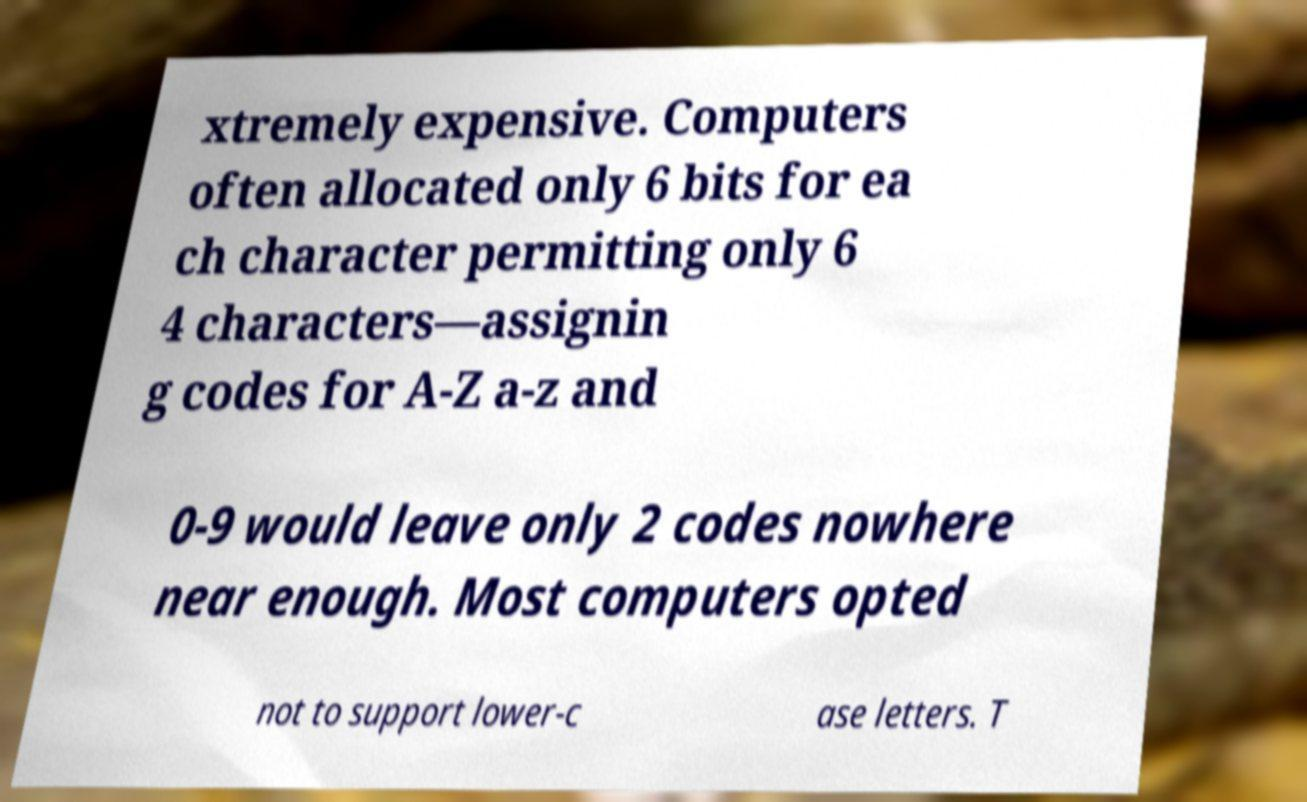There's text embedded in this image that I need extracted. Can you transcribe it verbatim? xtremely expensive. Computers often allocated only 6 bits for ea ch character permitting only 6 4 characters—assignin g codes for A-Z a-z and 0-9 would leave only 2 codes nowhere near enough. Most computers opted not to support lower-c ase letters. T 